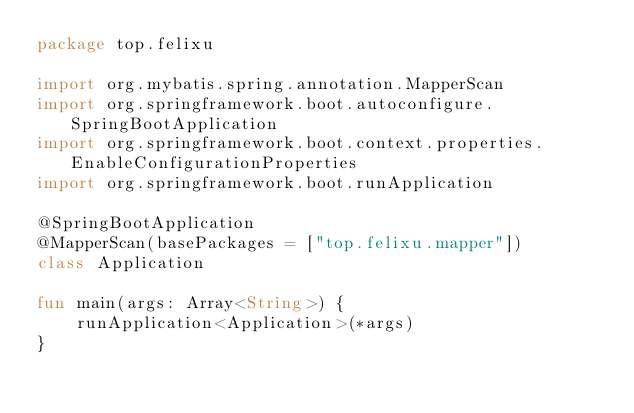Convert code to text. <code><loc_0><loc_0><loc_500><loc_500><_Kotlin_>package top.felixu

import org.mybatis.spring.annotation.MapperScan
import org.springframework.boot.autoconfigure.SpringBootApplication
import org.springframework.boot.context.properties.EnableConfigurationProperties
import org.springframework.boot.runApplication

@SpringBootApplication
@MapperScan(basePackages = ["top.felixu.mapper"])
class Application

fun main(args: Array<String>) {
    runApplication<Application>(*args)
}
</code> 